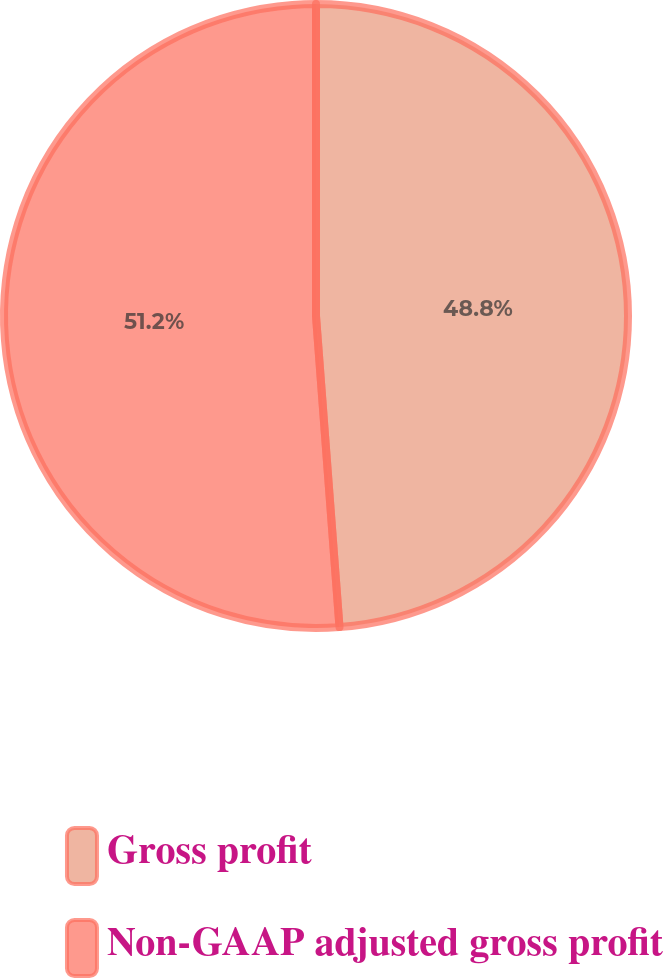Convert chart to OTSL. <chart><loc_0><loc_0><loc_500><loc_500><pie_chart><fcel>Gross profit<fcel>Non-GAAP adjusted gross profit<nl><fcel>48.8%<fcel>51.2%<nl></chart> 